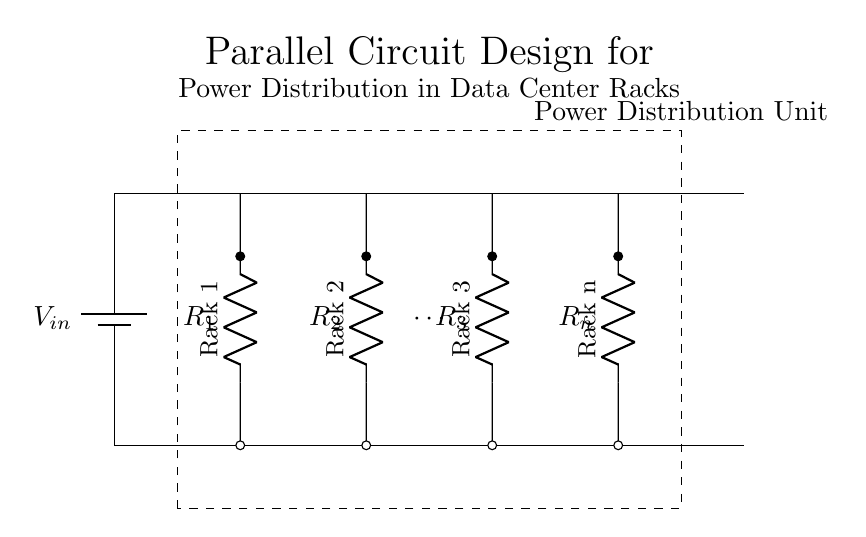What is the input voltage of this circuit? The input voltage is represented as V in and is indicated by the battery symbol at the top of the circuit diagram.
Answer: V in How many racks are represented in the circuit? The circuit explicitly shows three racks labeled Rack 1, Rack 2, and Rack 3, and also includes a label for Rack n, implying more racks can be added.
Answer: n (multiple) What type of components are used to represent the racks? The racks are represented using resistors, indicated by R1, R2, R3, and Rn in the diagram, which shows that they have resistance characteristics typical of electrical loads.
Answer: Resistors What is the arrangement of the racks in this power distribution? The arrangement of the racks is parallel, as each rack has its own pathway from the main bus, meaning they all connect directly to the same voltage source independently.
Answer: Parallel How can you determine the total resistance in this parallel circuit? In a parallel circuit, the total resistance is calculated using the formula 1/R_total = 1/R1 + 1/R2 + 1/R3 + ... + 1/Rn, which requires knowing the resistance values of each individual rack.
Answer: 1 / R_total = 1/R1 + 1/R2 + 1/R3 + ... + 1/Rn Why is the circuit designed in parallel for power distribution? The parallel design allows for each rack to operate independently; if one rack fails, it does not affect the others, providing better reliability and redundancy in power distribution for data center operations.
Answer: Reliability 